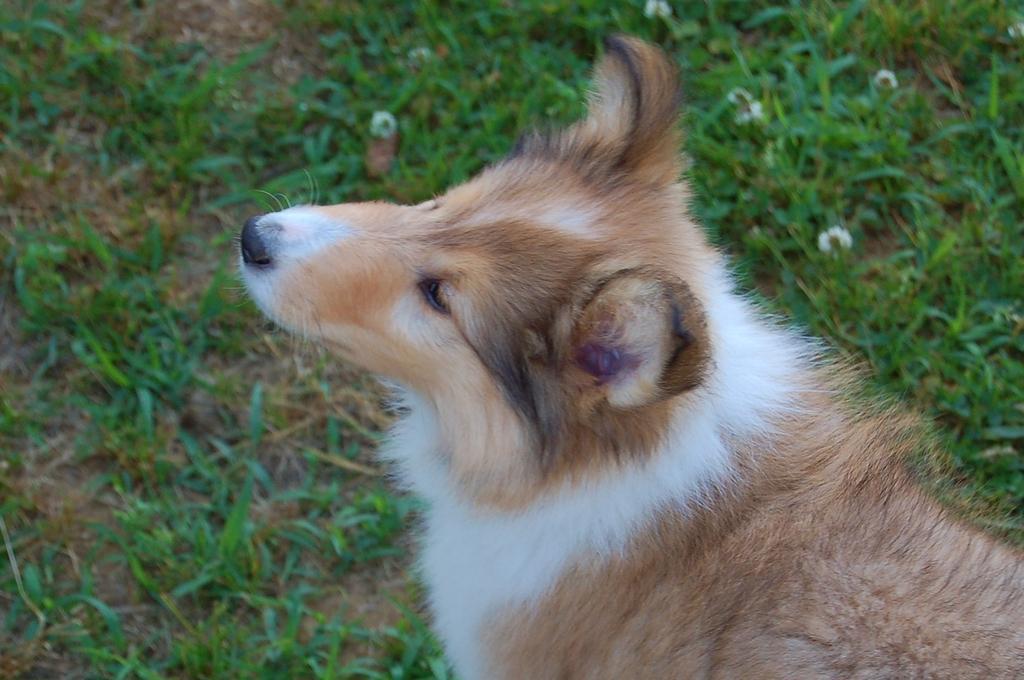How would you summarize this image in a sentence or two? In this picture we can see a dog and in the background we can see flowers, plants on the ground. 